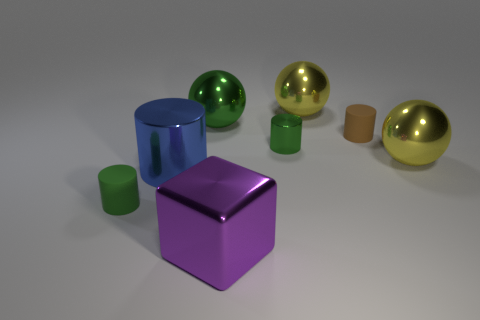Subtract 1 cylinders. How many cylinders are left? 3 Add 1 large blue rubber cubes. How many objects exist? 9 Subtract all spheres. How many objects are left? 5 Subtract all big blue shiny cylinders. Subtract all tiny brown cylinders. How many objects are left? 6 Add 6 big purple shiny blocks. How many big purple shiny blocks are left? 7 Add 2 green spheres. How many green spheres exist? 3 Subtract 0 purple cylinders. How many objects are left? 8 